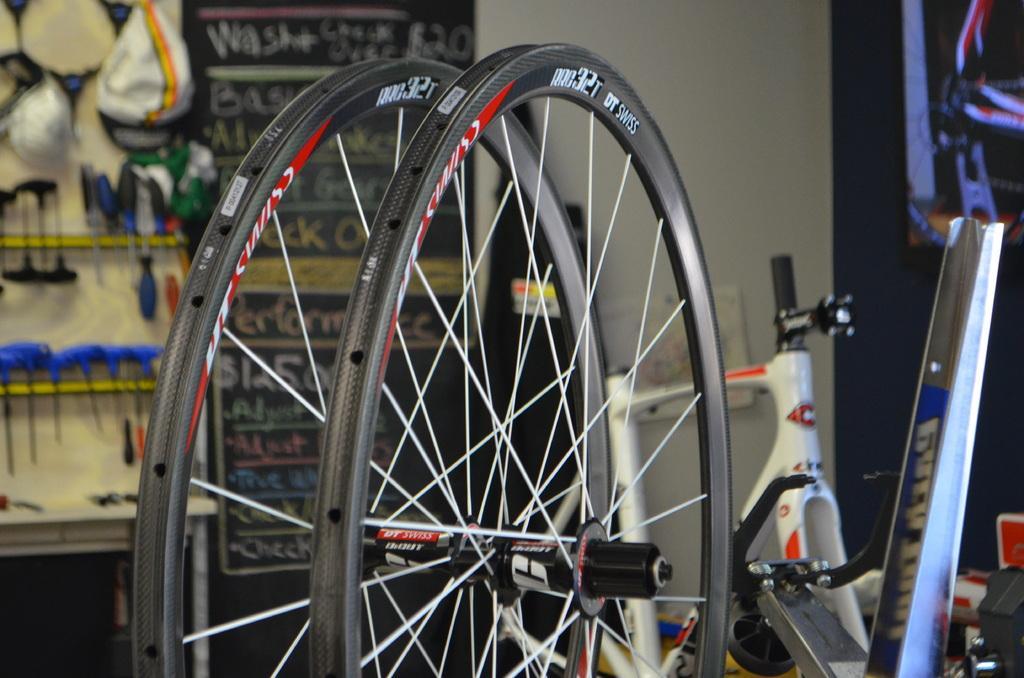In one or two sentences, can you explain what this image depicts? In this image, we can see the wheels and parts of a bicycle. We can see the wall with some objects attached to it. We can also see a poster with some text. We can see some objects on the right. We can also see some objects on the left. 